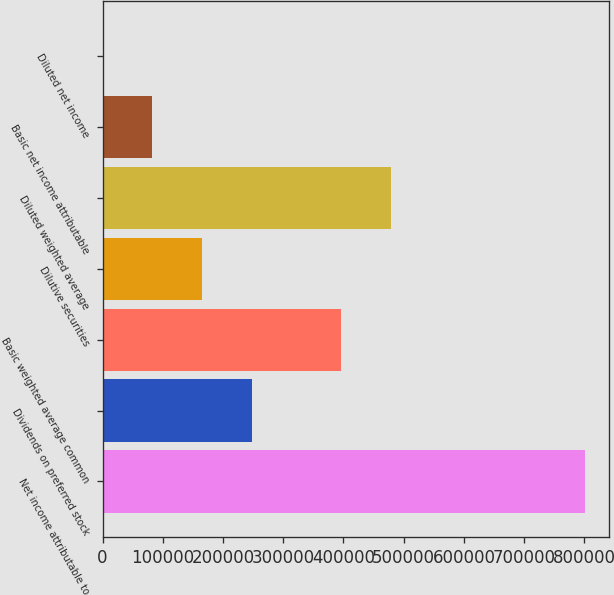Convert chart. <chart><loc_0><loc_0><loc_500><loc_500><bar_chart><fcel>Net income attributable to<fcel>Dividends on preferred stock<fcel>Basic weighted average common<fcel>Dilutive securities<fcel>Diluted weighted average<fcel>Basic net income attributable<fcel>Diluted net income<nl><fcel>801022<fcel>247474<fcel>395958<fcel>164984<fcel>478449<fcel>82492.8<fcel>2<nl></chart> 